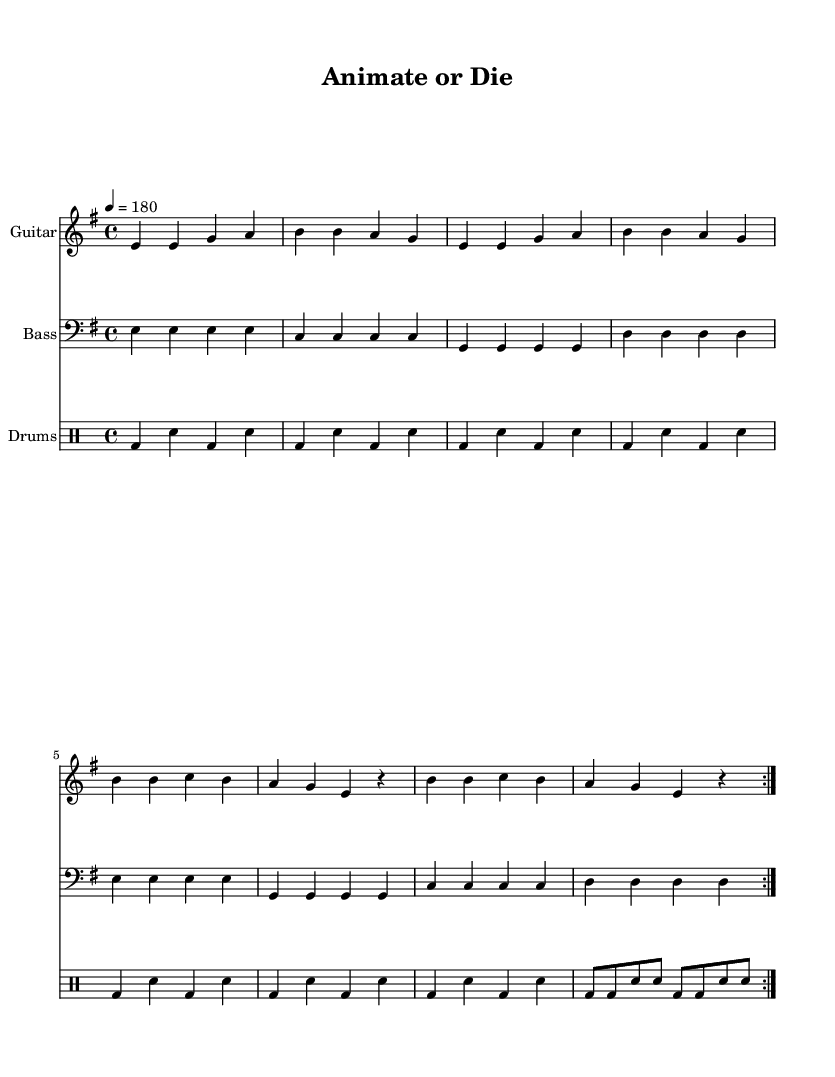What is the key signature of this music? The key signature is indicated by the presence of 1 sharp, which corresponds to E minor (or G major).
Answer: E minor What is the time signature of this music? The time signature is the fraction at the beginning of the staff, which shows there are 4 beats per measure and the quarter note gets one beat.
Answer: 4/4 What is the tempo marking for this track? The tempo marking, indicated as "4 = 180," tells us the beats per minute, showing the speed of the music.
Answer: 180 How many repetitions are indicated for the main sections? The music has a 'volta' marking with the number 2, indicating that the section is played twice.
Answer: 2 Which instruments are featured in this score? The score includes three staves, labeled as Guitar, Bass, and Drums, which represent the instrumentation used in the track.
Answer: Guitar, Bass, Drums What is the theme expressed in the lyrics? The lyrics in a punk context often highlight the DIY spirit and the struggles of independent creators, reemphasizing passion over commercialism.
Answer: DIY spirit What rhythmic device is used in the drum part? The drum part employs a consistent pattern of bass and snare hits, creating a driving, fast-paced beat typical for punk music.
Answer: Consistent pattern 